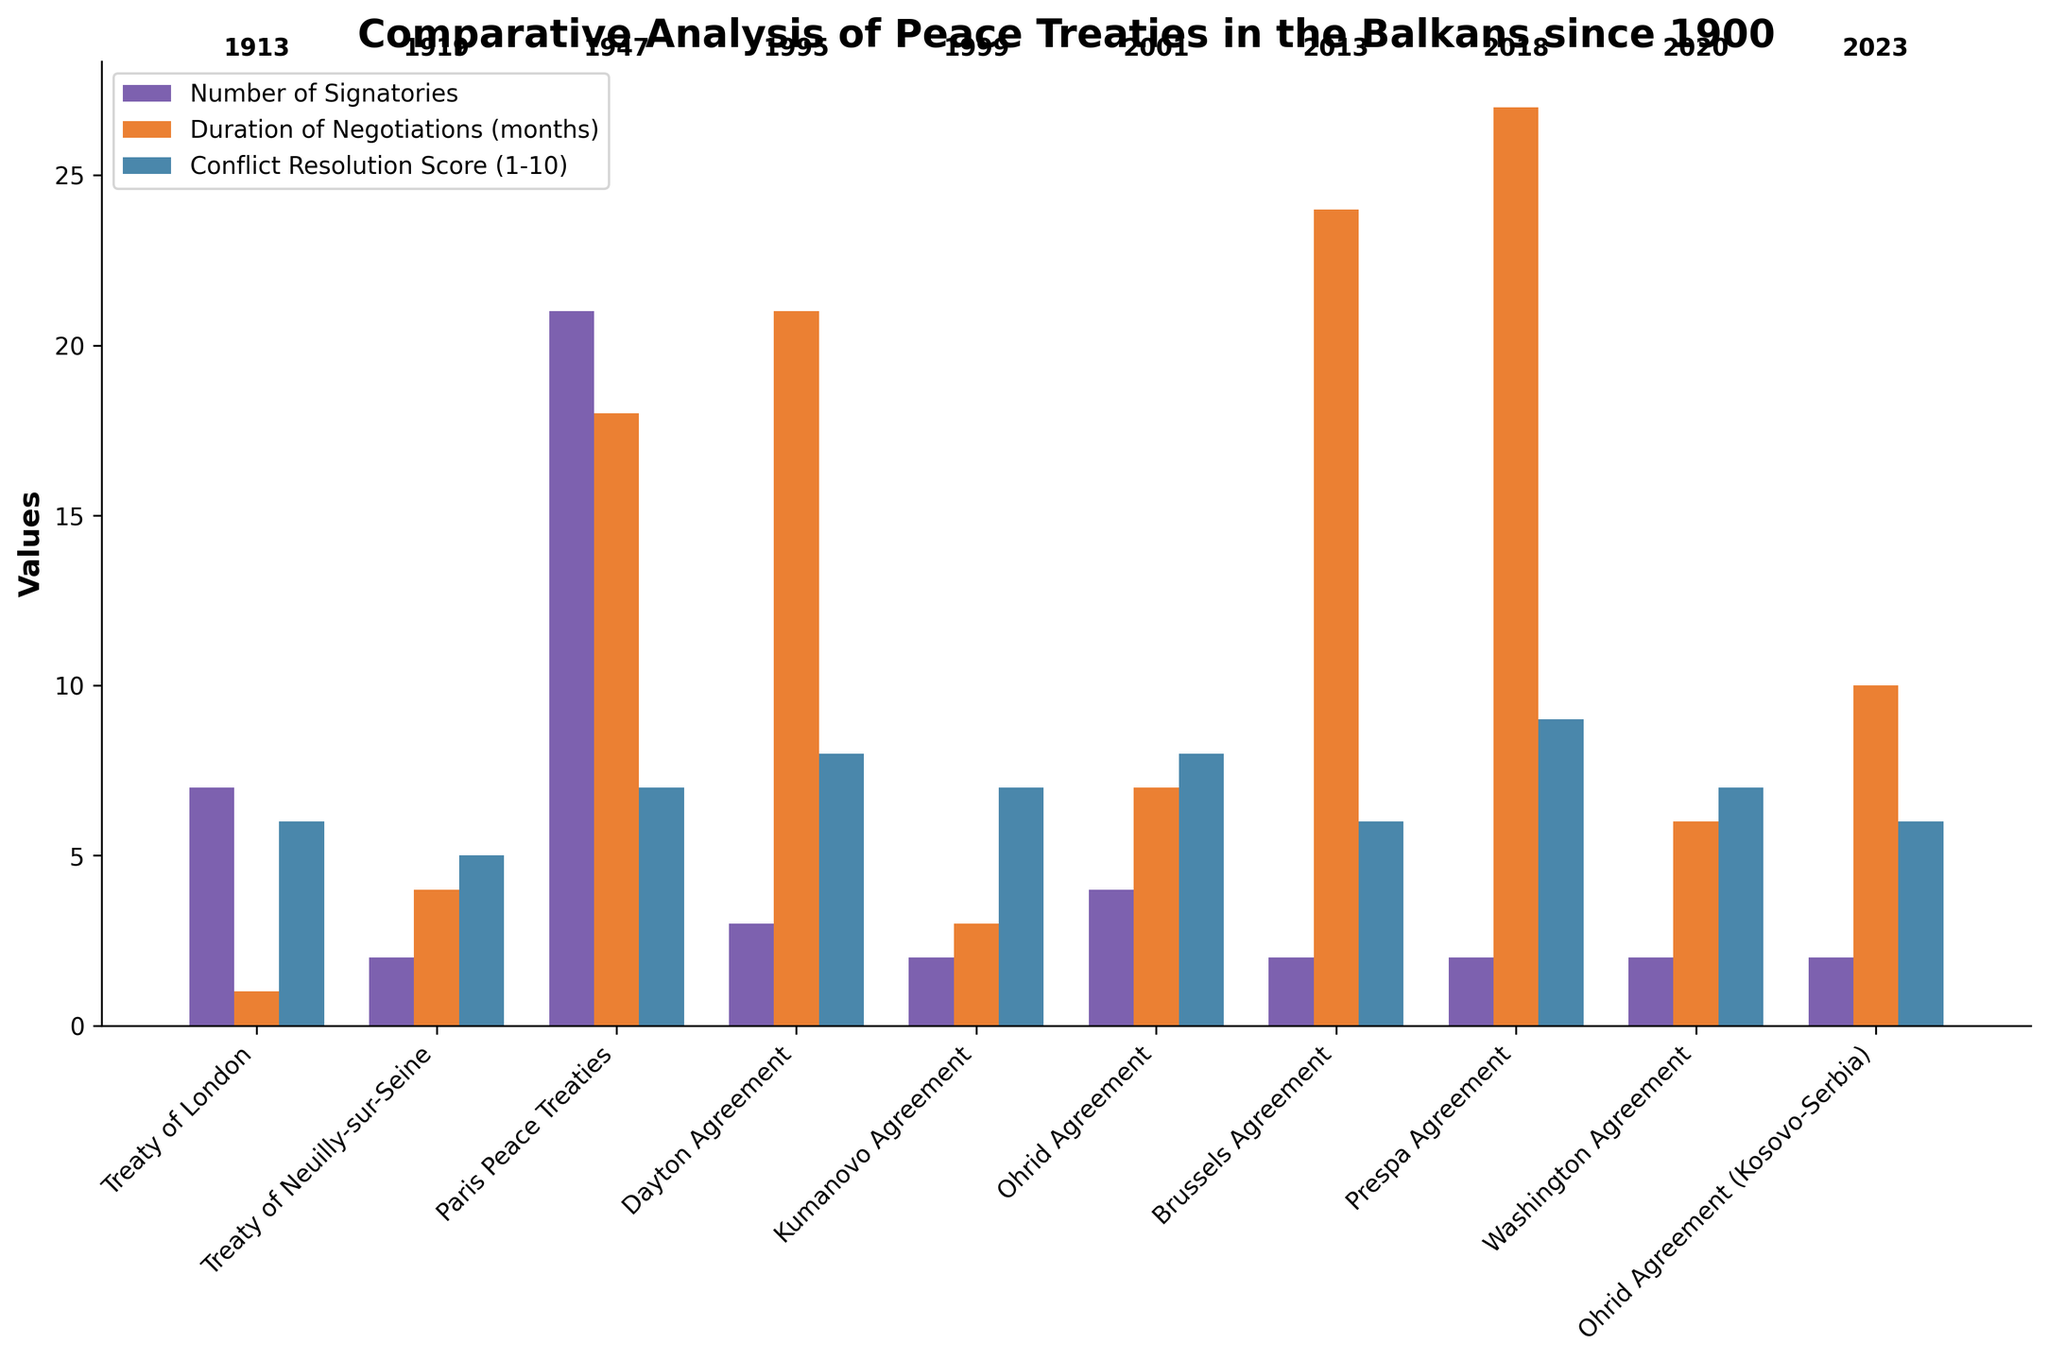Which treaty had the highest number of signatories? To find the answer, look at the height of the bars in the "Number of Signatories" category. The tallest bar corresponds to the Paris Peace Treaties.
Answer: Paris Peace Treaties Which treaty took the longest duration of negotiations? Find the tallest bar in the "Duration of Negotiations (months)" category. The highest bar corresponds to the Prespa Agreement.
Answer: Prespa Agreement What is the average Conflict Resolution Score of all the treaties? Sum all the Conflict Resolution Scores and divide by the number of treaties. (6 + 5 + 7 + 8 + 7 + 8 + 6 + 9 + 7 + 6) / 10 = 69 / 10 = 6.9
Answer: 6.9 Which treaty was signed most recently and what is its Conflict Resolution Score? Identify the most recent year on the x-axis and find the corresponding bar. The most recent year is 2023, which is the Ohrid Agreement (Kosovo-Serbia). Its Conflict Resolution Score bar height corresponds to 6.
Answer: 2023, 6 Which treaty had the shortest duration of negotiations? Look for the shortest bar in the "Duration of Negotiations (months)" category. The shortest bar corresponds to the Treaty of London, with 1 month of negotiation.
Answer: Treaty of London How many treaties had a Conflict Resolution Score of 7? Count the number of bars in the "Conflict Resolution Score" category that reach the value of 7. There are three: Paris Peace Treaties, Kumanovo Agreement, and Washington Agreement.
Answer: 3 What is the difference in the number of signatories between the Paris Peace Treaties and the Dayton Agreement? Find the heights of the bars for these treaties in the "Number of Signatories" category and subtract. Paris Peace Treaties has 21 signatories, and Dayton Agreement has 3. 21 - 3 = 18
Answer: 18 Compare the duration of negotiations between the Ohrid Agreement (2001) and the Brussels Agreement. Which had longer negotiations and by how much? Find the duration bar heights for these two agreements. Ohrid Agreement (2001) has a duration of 7 months, and Brussels Agreement has 24 months. 24 - 7 = 17 months
Answer: Brussels Agreement, 17 months Among the given treaties, which had an equal Conflict Resolution Score of 6? Identify the height of the bars in the "Conflict Resolution Score" category that match the value of 6. Three treaties match: Treaty of London, Brussels Agreement, and Ohrid Agreement (Kosovo-Serbia).
Answer: Treaty of London, Brussels Agreement, Ohrid Agreement (Kosovo-Serbia) Which three treaties had the longest duration of negotiations? Compare the heights of the bars in the "Duration of Negotiations (months)" category and select the top three highest ones. These correspond to the Prespa Agreement (27), Brussels Agreement (24), and Dayton Agreement (21).
Answer: Prespa Agreement, Brussels Agreement, Dayton Agreement 